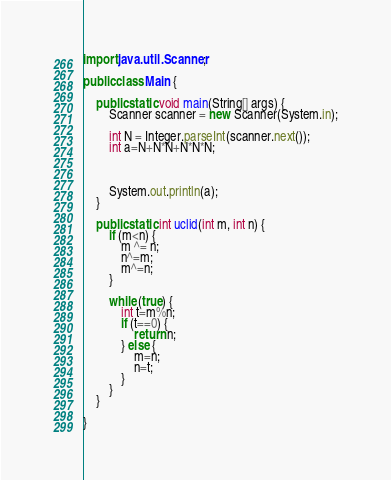<code> <loc_0><loc_0><loc_500><loc_500><_Java_>import java.util.Scanner;

public class Main {

	public static void main(String[] args) {
	    Scanner scanner = new Scanner(System.in);

	    int N = Integer.parseInt(scanner.next());
	    int a=N+N*N+N*N*N;



	    System.out.println(a);
	}

	public static int uclid(int m, int n) {
		if (m<n) {
			m ^= n;
			n^=m;
			m^=n;
		}

		while (true) {
			int t=m%n;
			if (t==0) {
				return n;
			} else {
				m=n;
				n=t;
			}
		}
	}

}</code> 